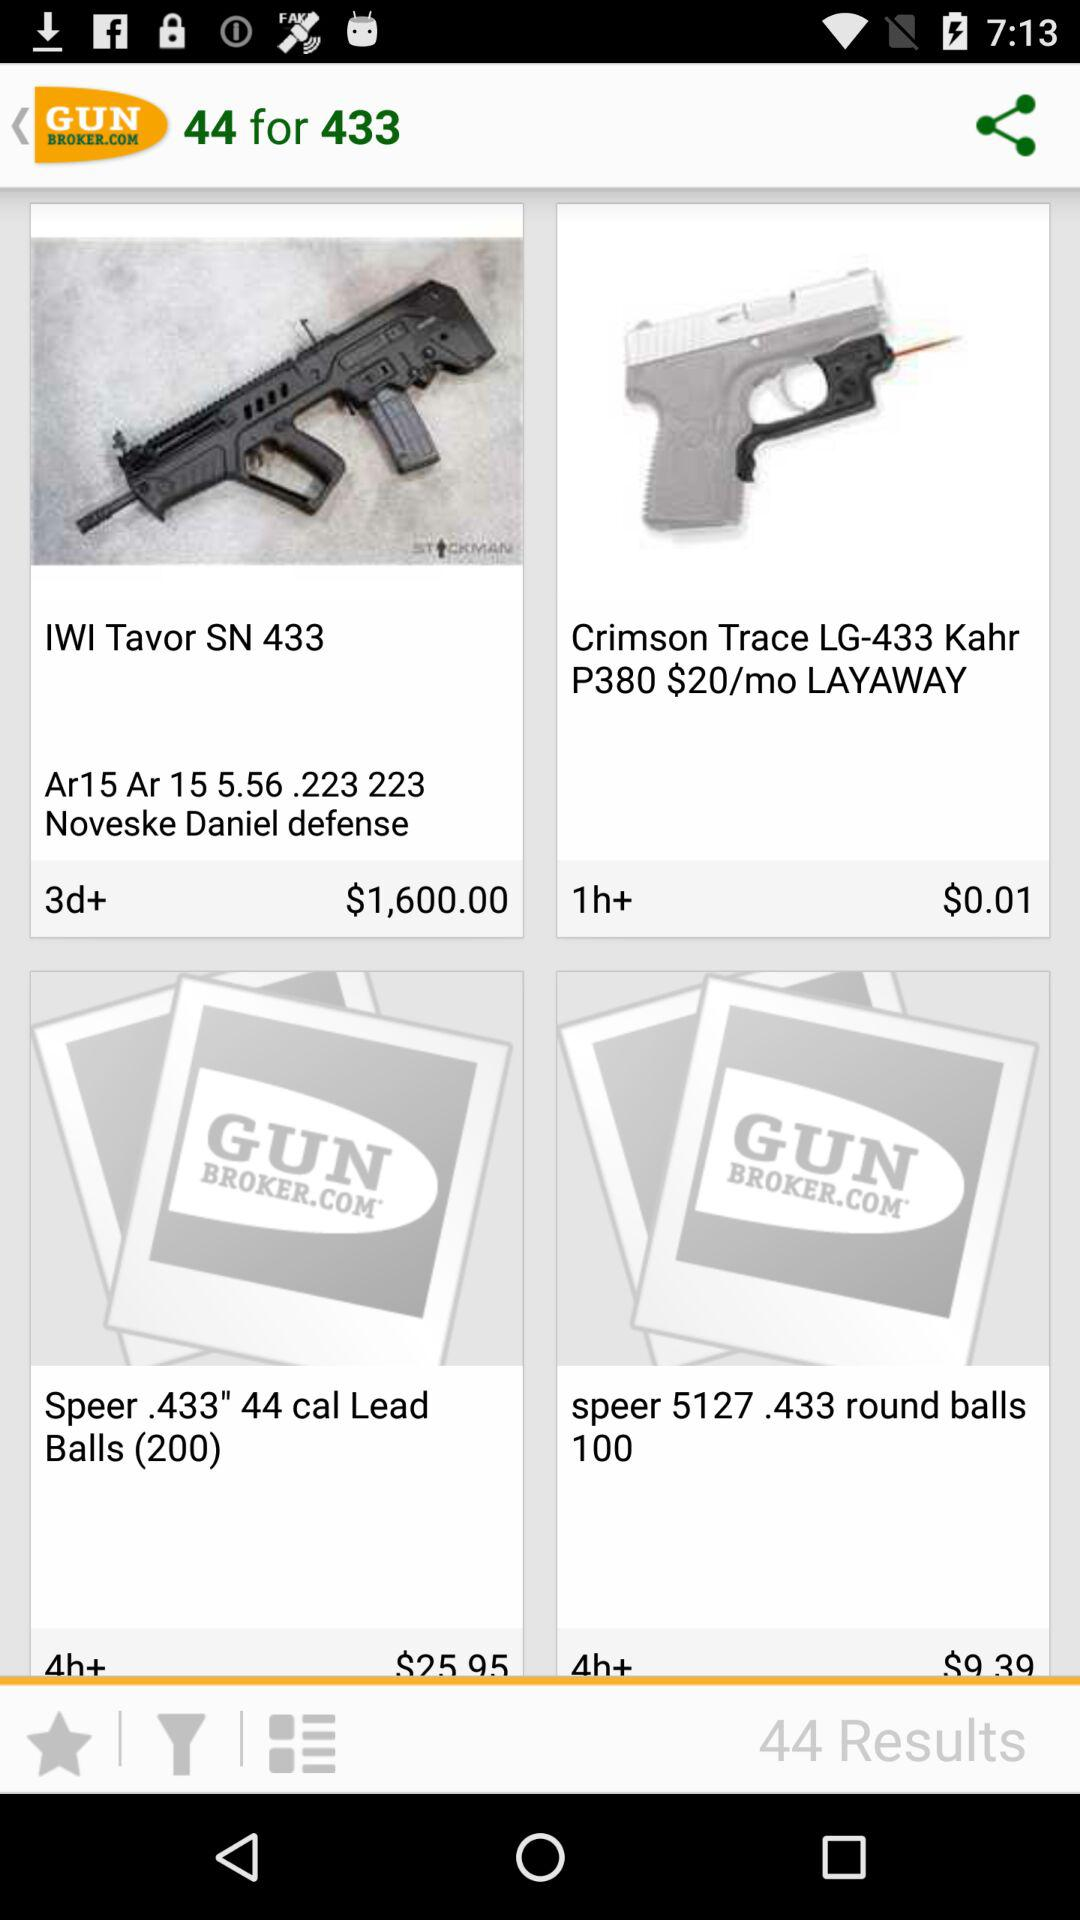What is the price of "IWI Tavor SN 433"? The price of "IWI Tavor SN 433" is $1,600. 